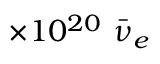Convert formula to latex. <formula><loc_0><loc_0><loc_500><loc_500>\times 1 0 ^ { 2 0 } \ B a r { \nu } _ { e }</formula> 